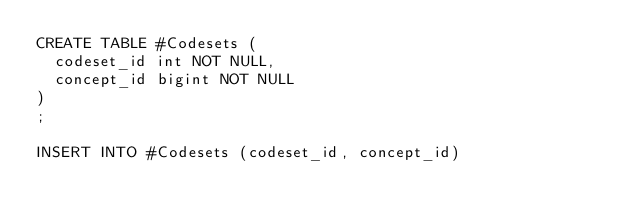Convert code to text. <code><loc_0><loc_0><loc_500><loc_500><_SQL_>CREATE TABLE #Codesets (
  codeset_id int NOT NULL,
  concept_id bigint NOT NULL
)
;

INSERT INTO #Codesets (codeset_id, concept_id)</code> 